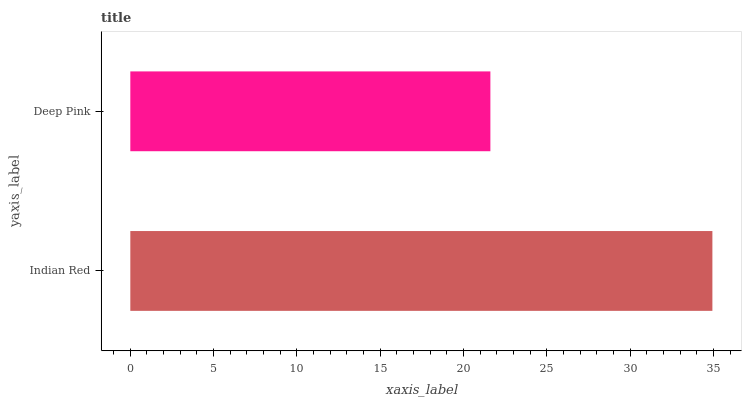Is Deep Pink the minimum?
Answer yes or no. Yes. Is Indian Red the maximum?
Answer yes or no. Yes. Is Deep Pink the maximum?
Answer yes or no. No. Is Indian Red greater than Deep Pink?
Answer yes or no. Yes. Is Deep Pink less than Indian Red?
Answer yes or no. Yes. Is Deep Pink greater than Indian Red?
Answer yes or no. No. Is Indian Red less than Deep Pink?
Answer yes or no. No. Is Indian Red the high median?
Answer yes or no. Yes. Is Deep Pink the low median?
Answer yes or no. Yes. Is Deep Pink the high median?
Answer yes or no. No. Is Indian Red the low median?
Answer yes or no. No. 